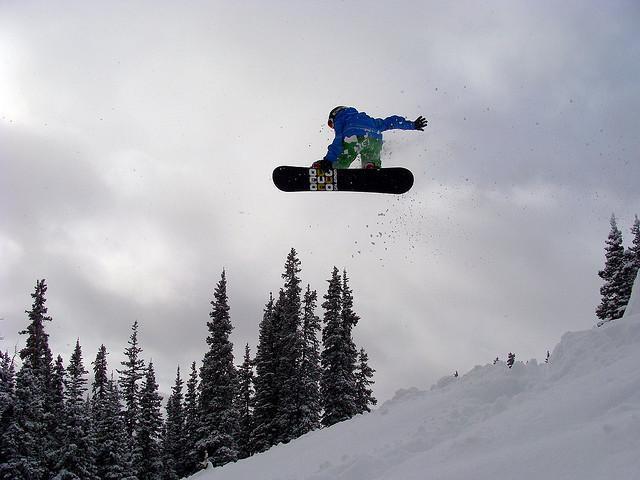How many people are there?
Give a very brief answer. 1. 